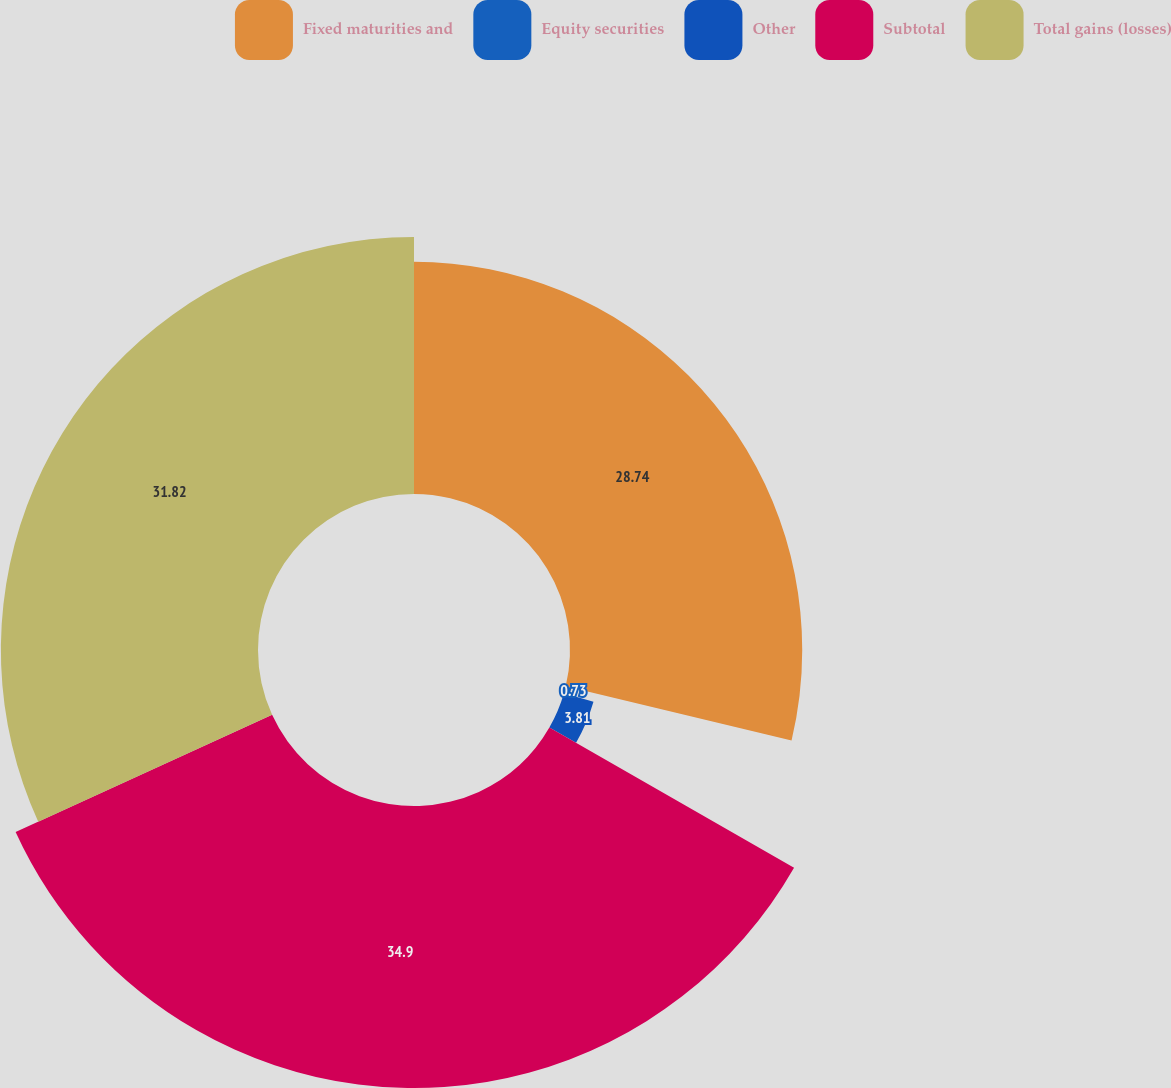Convert chart. <chart><loc_0><loc_0><loc_500><loc_500><pie_chart><fcel>Fixed maturities and<fcel>Equity securities<fcel>Other<fcel>Subtotal<fcel>Total gains (losses)<nl><fcel>28.74%<fcel>0.73%<fcel>3.81%<fcel>34.9%<fcel>31.82%<nl></chart> 